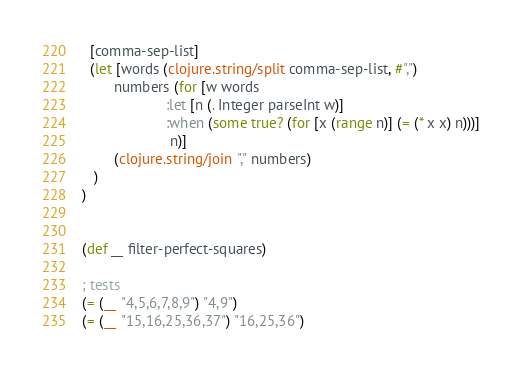<code> <loc_0><loc_0><loc_500><loc_500><_Clojure_>  [comma-sep-list]
  (let [words (clojure.string/split comma-sep-list, #",")
        numbers (for [w words
                     :let [n (. Integer parseInt w)]
                     :when (some true? (for [x (range n)] (= (* x x) n)))]
                      n)]
        (clojure.string/join "," numbers)
   )
)


(def __ filter-perfect-squares)

; tests
(= (__ "4,5,6,7,8,9") "4,9")
(= (__ "15,16,25,36,37") "16,25,36")
</code> 